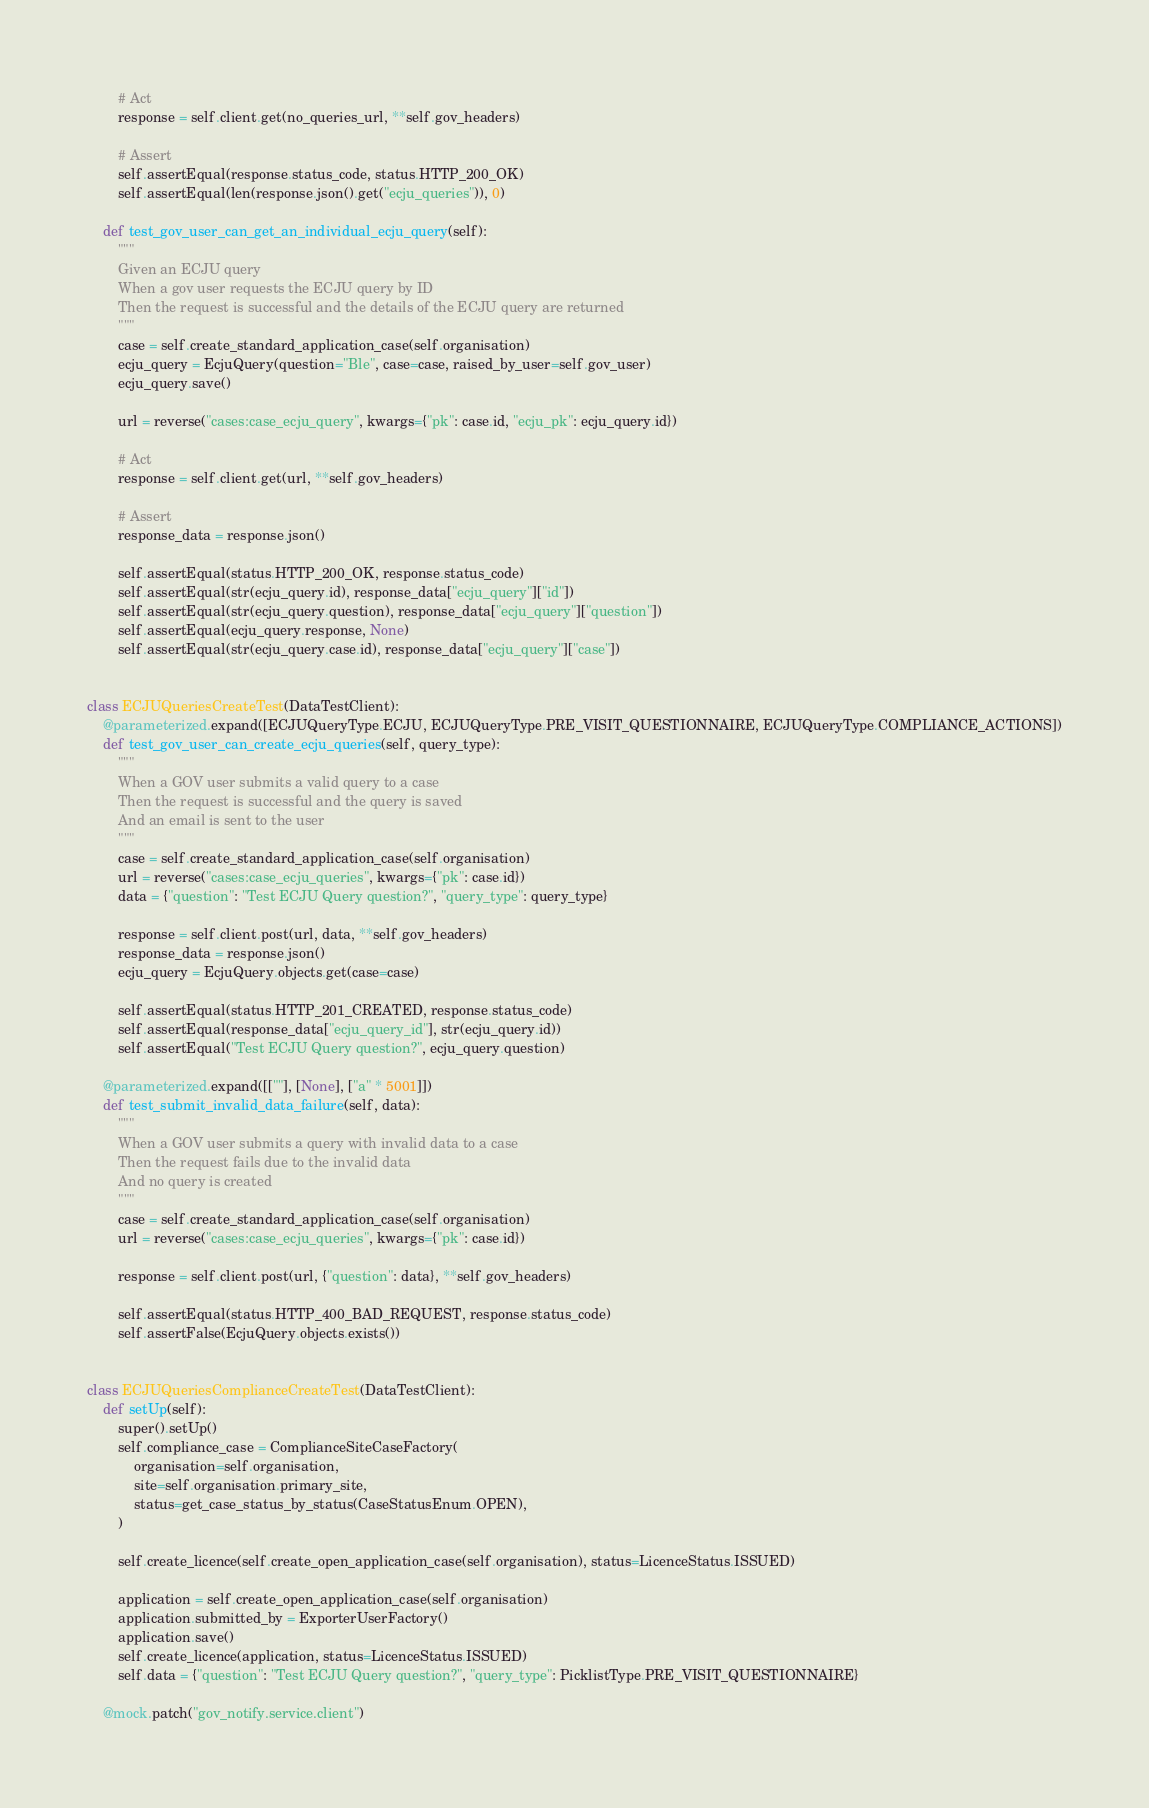Convert code to text. <code><loc_0><loc_0><loc_500><loc_500><_Python_>        # Act
        response = self.client.get(no_queries_url, **self.gov_headers)

        # Assert
        self.assertEqual(response.status_code, status.HTTP_200_OK)
        self.assertEqual(len(response.json().get("ecju_queries")), 0)

    def test_gov_user_can_get_an_individual_ecju_query(self):
        """
        Given an ECJU query
        When a gov user requests the ECJU query by ID
        Then the request is successful and the details of the ECJU query are returned
        """
        case = self.create_standard_application_case(self.organisation)
        ecju_query = EcjuQuery(question="Ble", case=case, raised_by_user=self.gov_user)
        ecju_query.save()

        url = reverse("cases:case_ecju_query", kwargs={"pk": case.id, "ecju_pk": ecju_query.id})

        # Act
        response = self.client.get(url, **self.gov_headers)

        # Assert
        response_data = response.json()

        self.assertEqual(status.HTTP_200_OK, response.status_code)
        self.assertEqual(str(ecju_query.id), response_data["ecju_query"]["id"])
        self.assertEqual(str(ecju_query.question), response_data["ecju_query"]["question"])
        self.assertEqual(ecju_query.response, None)
        self.assertEqual(str(ecju_query.case.id), response_data["ecju_query"]["case"])


class ECJUQueriesCreateTest(DataTestClient):
    @parameterized.expand([ECJUQueryType.ECJU, ECJUQueryType.PRE_VISIT_QUESTIONNAIRE, ECJUQueryType.COMPLIANCE_ACTIONS])
    def test_gov_user_can_create_ecju_queries(self, query_type):
        """
        When a GOV user submits a valid query to a case
        Then the request is successful and the query is saved
        And an email is sent to the user
        """
        case = self.create_standard_application_case(self.organisation)
        url = reverse("cases:case_ecju_queries", kwargs={"pk": case.id})
        data = {"question": "Test ECJU Query question?", "query_type": query_type}

        response = self.client.post(url, data, **self.gov_headers)
        response_data = response.json()
        ecju_query = EcjuQuery.objects.get(case=case)

        self.assertEqual(status.HTTP_201_CREATED, response.status_code)
        self.assertEqual(response_data["ecju_query_id"], str(ecju_query.id))
        self.assertEqual("Test ECJU Query question?", ecju_query.question)

    @parameterized.expand([[""], [None], ["a" * 5001]])
    def test_submit_invalid_data_failure(self, data):
        """
        When a GOV user submits a query with invalid data to a case
        Then the request fails due to the invalid data
        And no query is created
        """
        case = self.create_standard_application_case(self.organisation)
        url = reverse("cases:case_ecju_queries", kwargs={"pk": case.id})

        response = self.client.post(url, {"question": data}, **self.gov_headers)

        self.assertEqual(status.HTTP_400_BAD_REQUEST, response.status_code)
        self.assertFalse(EcjuQuery.objects.exists())


class ECJUQueriesComplianceCreateTest(DataTestClient):
    def setUp(self):
        super().setUp()
        self.compliance_case = ComplianceSiteCaseFactory(
            organisation=self.organisation,
            site=self.organisation.primary_site,
            status=get_case_status_by_status(CaseStatusEnum.OPEN),
        )

        self.create_licence(self.create_open_application_case(self.organisation), status=LicenceStatus.ISSUED)

        application = self.create_open_application_case(self.organisation)
        application.submitted_by = ExporterUserFactory()
        application.save()
        self.create_licence(application, status=LicenceStatus.ISSUED)
        self.data = {"question": "Test ECJU Query question?", "query_type": PicklistType.PRE_VISIT_QUESTIONNAIRE}

    @mock.patch("gov_notify.service.client")</code> 